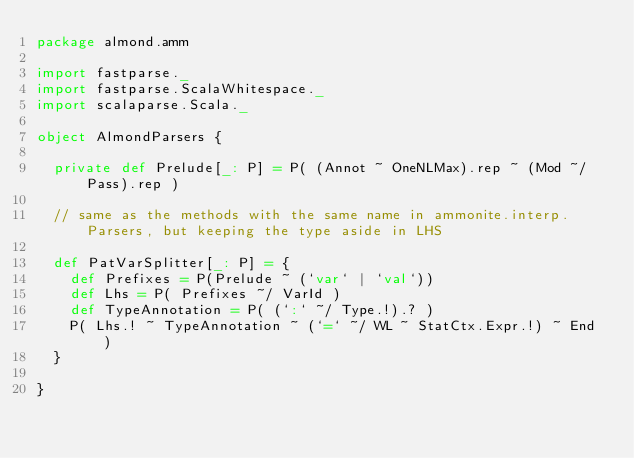Convert code to text. <code><loc_0><loc_0><loc_500><loc_500><_Scala_>package almond.amm

import fastparse._
import fastparse.ScalaWhitespace._
import scalaparse.Scala._

object AlmondParsers {

  private def Prelude[_: P] = P( (Annot ~ OneNLMax).rep ~ (Mod ~/ Pass).rep )

  // same as the methods with the same name in ammonite.interp.Parsers, but keeping the type aside in LHS

  def PatVarSplitter[_: P] = {
    def Prefixes = P(Prelude ~ (`var` | `val`))
    def Lhs = P( Prefixes ~/ VarId )
    def TypeAnnotation = P( (`:` ~/ Type.!).? )
    P( Lhs.! ~ TypeAnnotation ~ (`=` ~/ WL ~ StatCtx.Expr.!) ~ End )
  }

}
</code> 